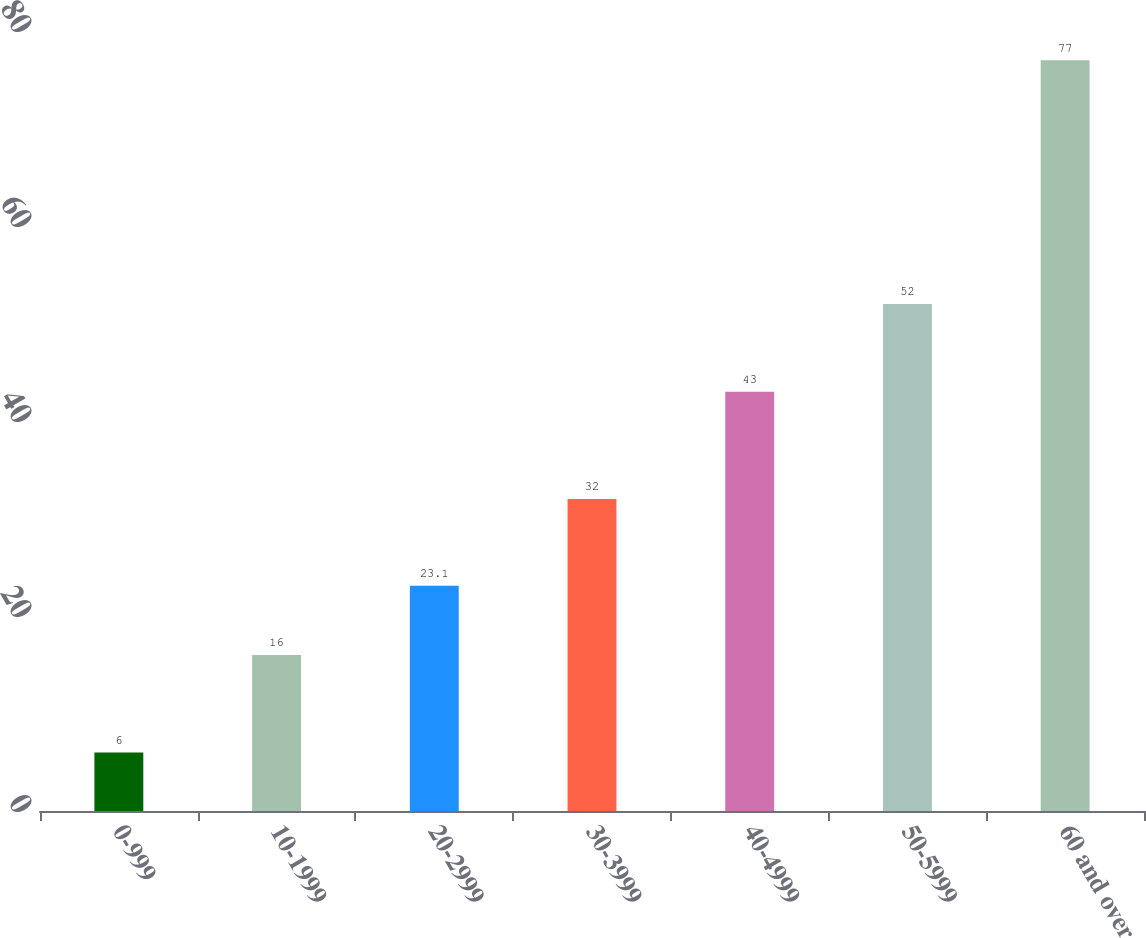Convert chart to OTSL. <chart><loc_0><loc_0><loc_500><loc_500><bar_chart><fcel>0-999<fcel>10-1999<fcel>20-2999<fcel>30-3999<fcel>40-4999<fcel>50-5999<fcel>60 and over<nl><fcel>6<fcel>16<fcel>23.1<fcel>32<fcel>43<fcel>52<fcel>77<nl></chart> 